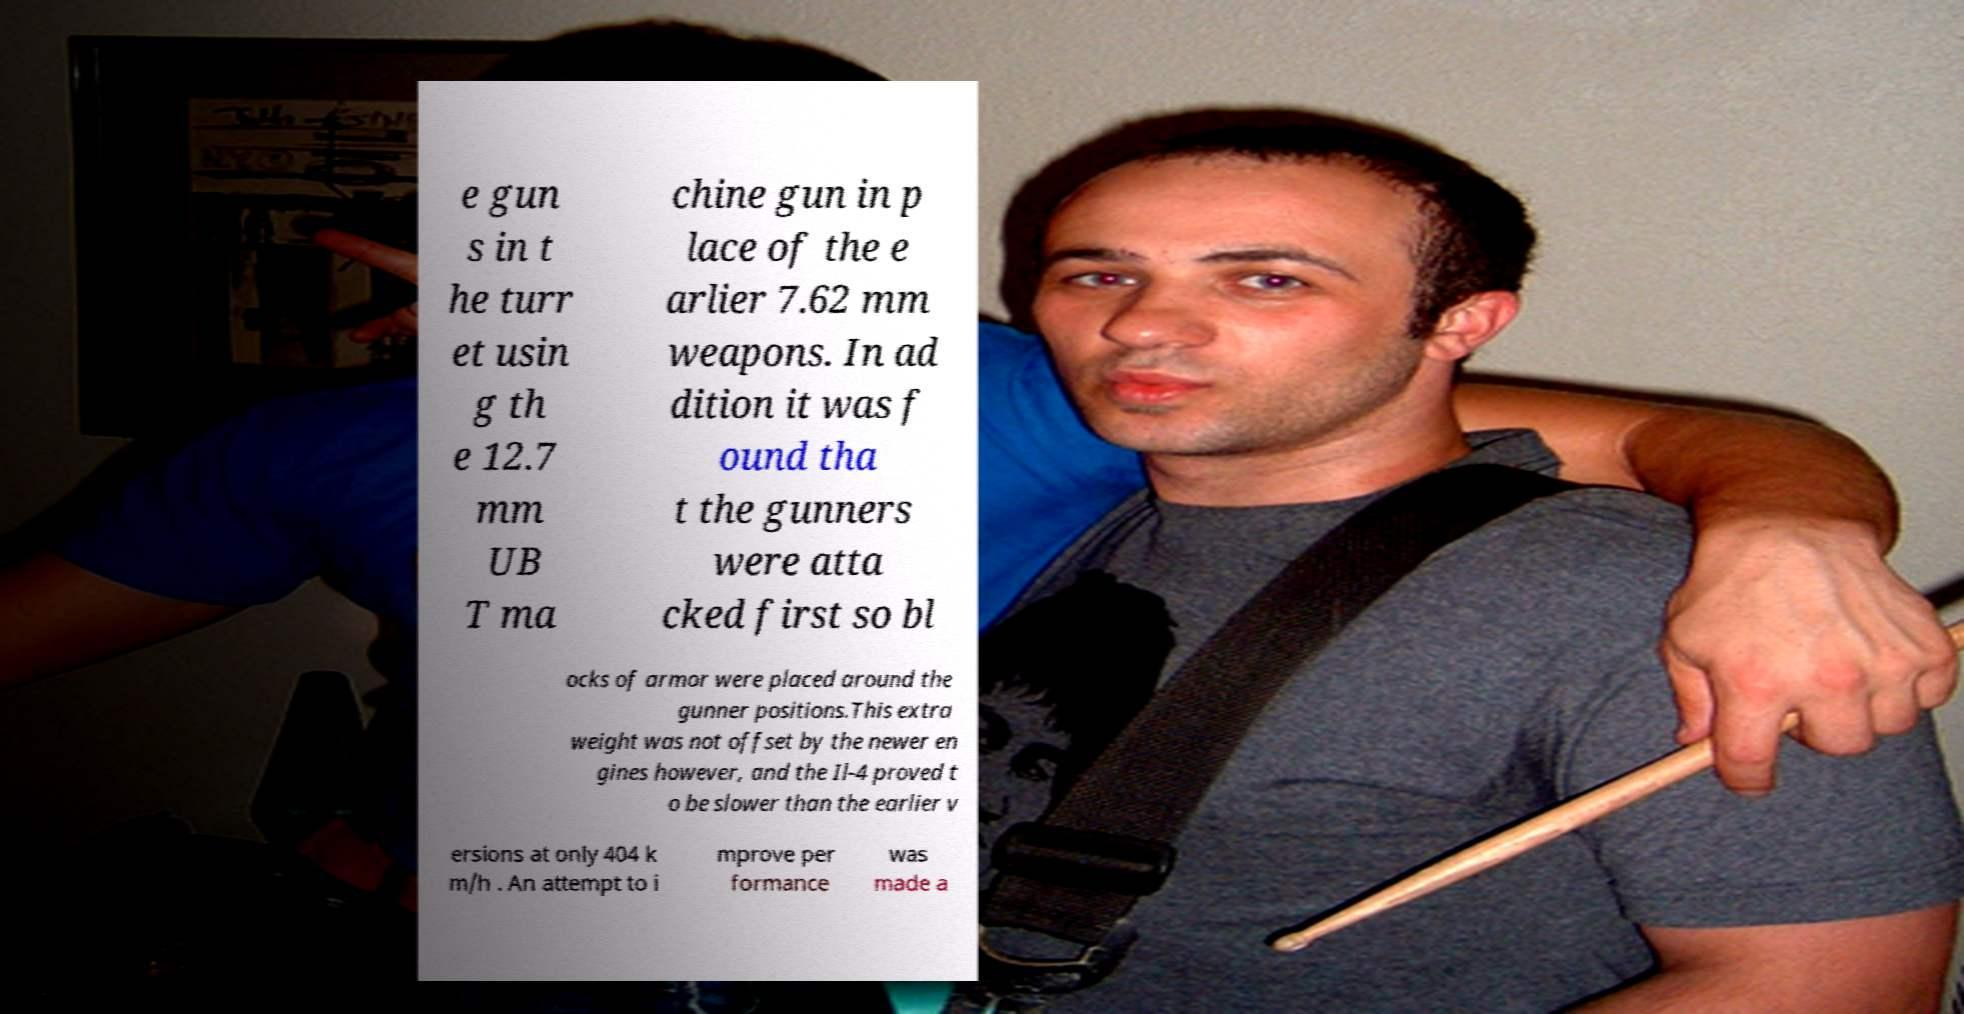What messages or text are displayed in this image? I need them in a readable, typed format. e gun s in t he turr et usin g th e 12.7 mm UB T ma chine gun in p lace of the e arlier 7.62 mm weapons. In ad dition it was f ound tha t the gunners were atta cked first so bl ocks of armor were placed around the gunner positions.This extra weight was not offset by the newer en gines however, and the Il-4 proved t o be slower than the earlier v ersions at only 404 k m/h . An attempt to i mprove per formance was made a 